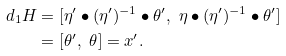<formula> <loc_0><loc_0><loc_500><loc_500>d _ { 1 } H & = [ \eta ^ { \prime } \bullet ( \eta ^ { \prime } ) ^ { - 1 } \bullet \theta ^ { \prime } , \ \eta \bullet ( \eta ^ { \prime } ) ^ { - 1 } \bullet \theta ^ { \prime } ] \\ & = [ \theta ^ { \prime } , \ \theta ] = x ^ { \prime } .</formula> 